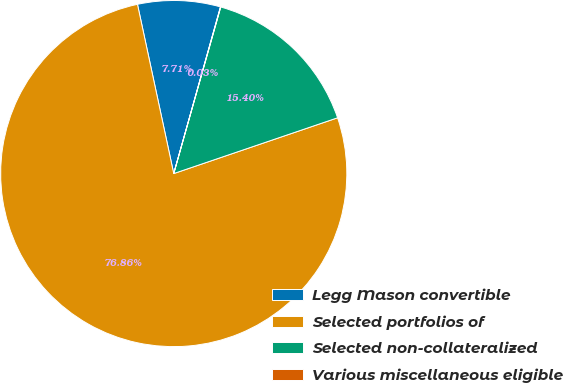Convert chart to OTSL. <chart><loc_0><loc_0><loc_500><loc_500><pie_chart><fcel>Legg Mason convertible<fcel>Selected portfolios of<fcel>Selected non-collateralized<fcel>Various miscellaneous eligible<nl><fcel>7.71%<fcel>76.86%<fcel>15.4%<fcel>0.03%<nl></chart> 